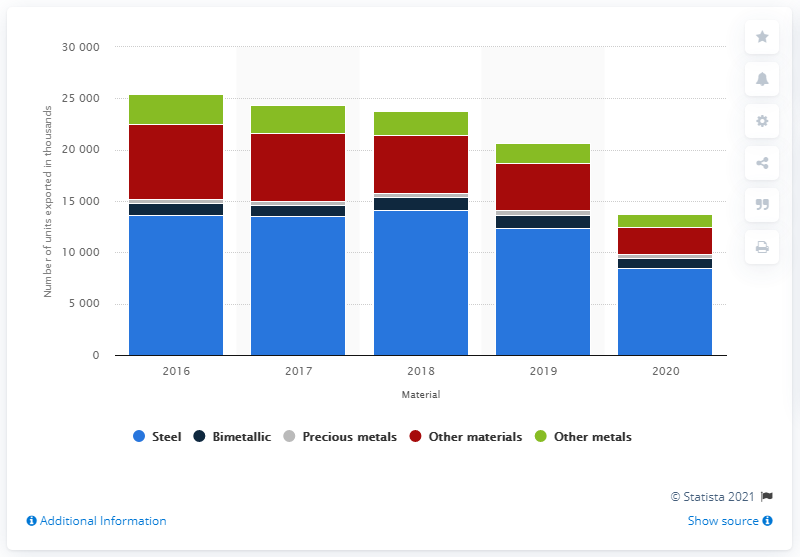Draw attention to some important aspects in this diagram. In 2020, a total of 8,439 units of Swiss steel watches were exported worldwide. 